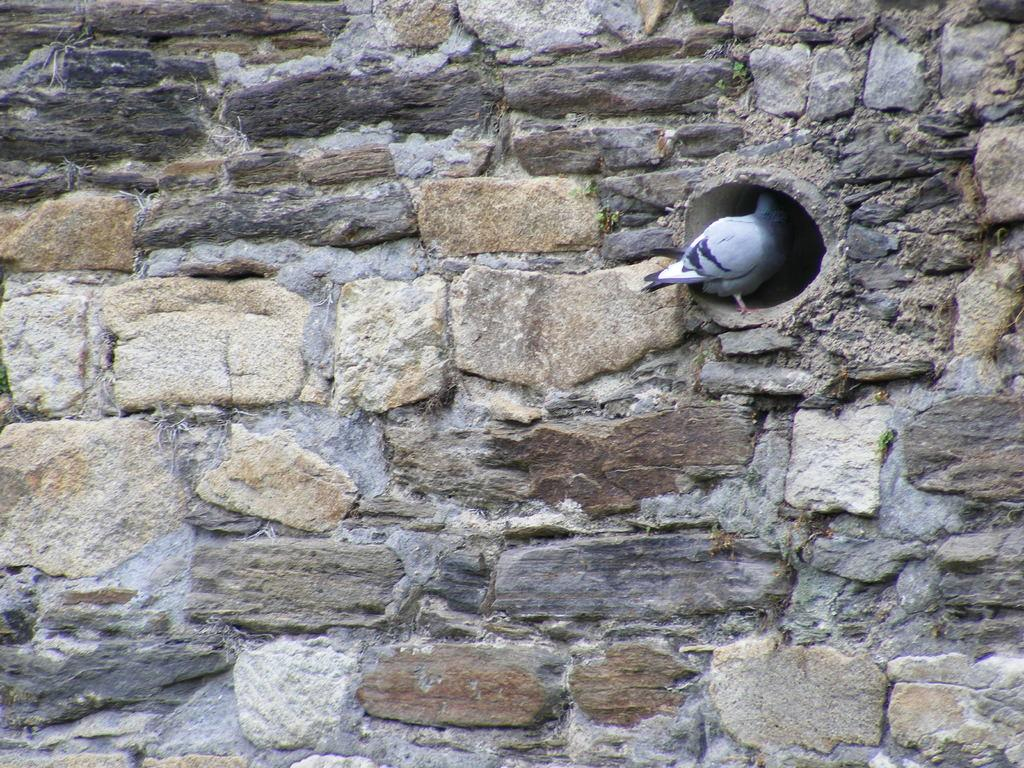What type of animal is in the image? There is a pigeon in the image. Where is the pigeon located? The pigeon is in a hole. What is the hole located on? The hole is on a stone wall. How does the pigeon plan to reach the island in the image? There is no island present in the image, so the pigeon cannot plan to reach it. 